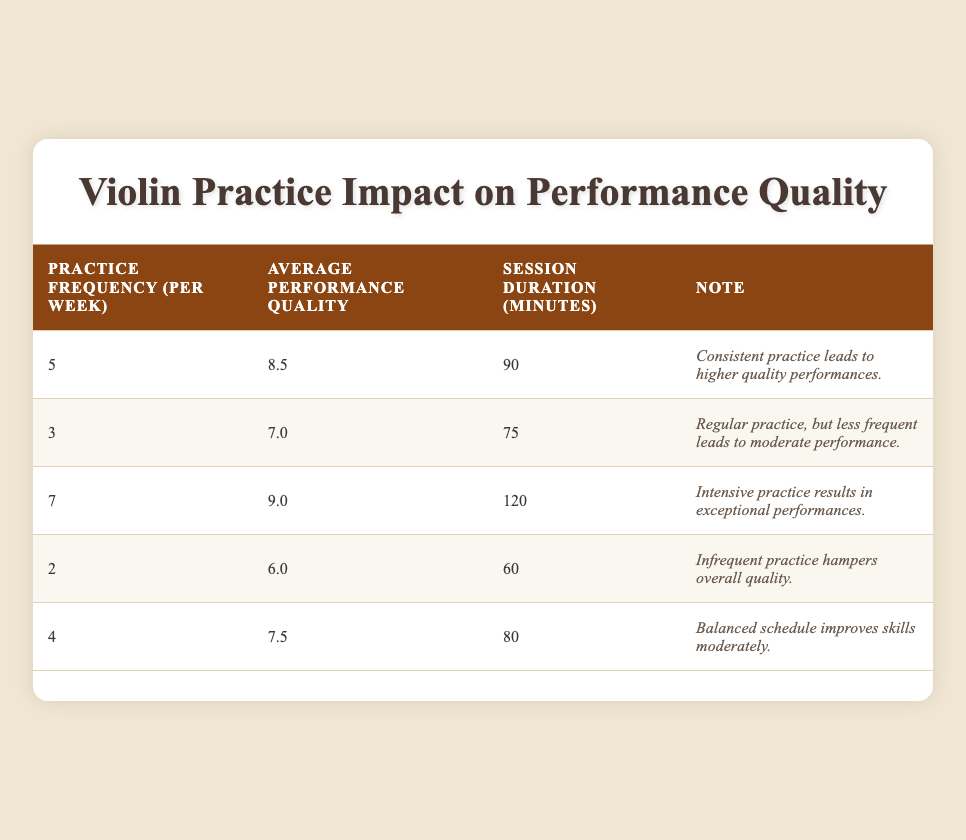What is the highest practice frequency recorded? From the table, the highest practice frequency is 7, as indicated in the row with that entry.
Answer: 7 What is the average performance quality rating for practicing 4 times a week? The average performance quality rating for a practice frequency of 4 times a week is 7.5, as shown in the corresponding row.
Answer: 7.5 Is there a correlation between practice frequency and average performance quality rating? Yes, generally, as the frequency of practice increases, the average performance quality rating also increases. For example, 5 practices yield 8.5 and 7 yields 9.0.
Answer: Yes What is the average session duration for the highest performance quality rating? The highest performance quality rating is 9.0 for 7 practices per week, with a session duration of 120 minutes. Hence, the average session duration is 120 minutes.
Answer: 120 minutes If a violinist practices 5 times a week for 90 minutes per session, how does that compare to practicing 3 times a week for 75 minutes? Practicing 5 times a week for 90 minutes results in an 8.5 performance rating, while practicing 3 times a week for 75 minutes yields a 7.0 rating. This shows that more frequent and longer sessions improve performance quality.
Answer: 8.5 vs 7.0 How many total performance quality ratings are above 8.0? To determine this, we look at the values: 8.5 and 9.0. There are two ratings that exceed 8.0.
Answer: 2 Are there any notes indicating that infrequent practice is detrimental? Yes, the note for the row with a practice frequency of 2 states, "Infrequent practice hampers overall quality."
Answer: Yes What is the difference in average performance quality rating between 3 and 5 times a week? The average performance quality rating for 3 times a week is 7.0 and for 5 times a week is 8.5. The difference is 8.5 - 7.0 = 1.5.
Answer: 1.5 